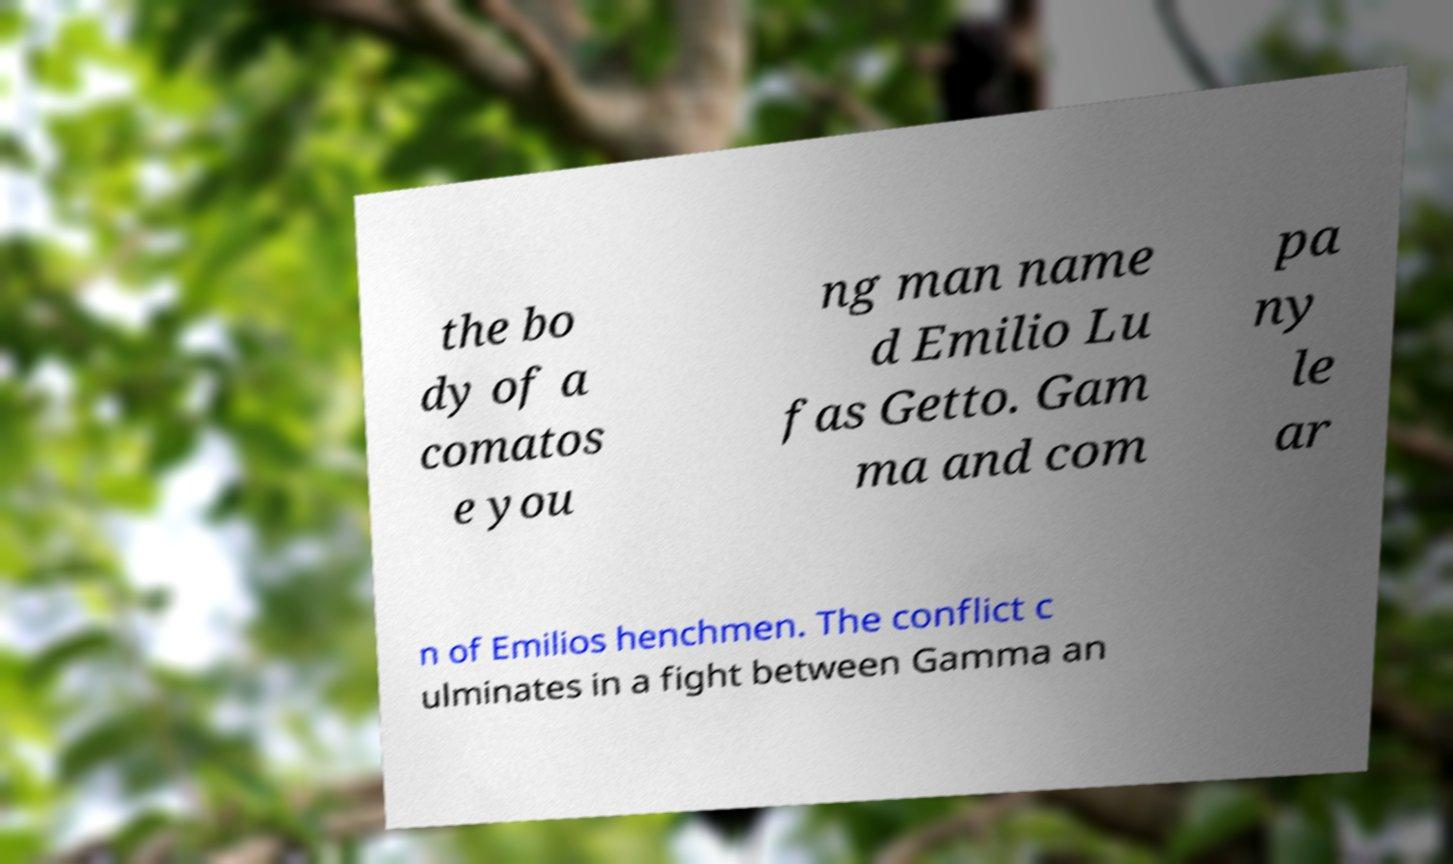Please read and relay the text visible in this image. What does it say? the bo dy of a comatos e you ng man name d Emilio Lu fas Getto. Gam ma and com pa ny le ar n of Emilios henchmen. The conflict c ulminates in a fight between Gamma an 